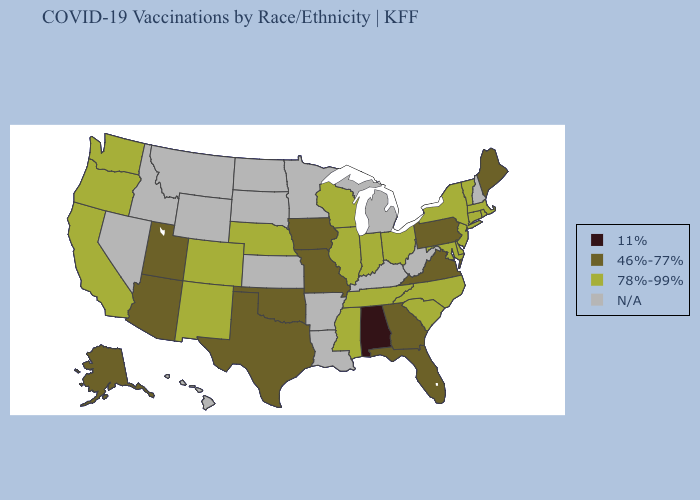Name the states that have a value in the range 78%-99%?
Answer briefly. California, Colorado, Connecticut, Delaware, Illinois, Indiana, Maryland, Massachusetts, Mississippi, Nebraska, New Jersey, New Mexico, New York, North Carolina, Ohio, Oregon, Rhode Island, South Carolina, Tennessee, Vermont, Washington, Wisconsin. What is the highest value in the South ?
Write a very short answer. 78%-99%. Name the states that have a value in the range N/A?
Concise answer only. Arkansas, Hawaii, Idaho, Kansas, Kentucky, Louisiana, Michigan, Minnesota, Montana, Nevada, New Hampshire, North Dakota, South Dakota, West Virginia, Wyoming. Name the states that have a value in the range 11%?
Write a very short answer. Alabama. What is the lowest value in the USA?
Concise answer only. 11%. Name the states that have a value in the range 78%-99%?
Keep it brief. California, Colorado, Connecticut, Delaware, Illinois, Indiana, Maryland, Massachusetts, Mississippi, Nebraska, New Jersey, New Mexico, New York, North Carolina, Ohio, Oregon, Rhode Island, South Carolina, Tennessee, Vermont, Washington, Wisconsin. Does Alabama have the lowest value in the USA?
Short answer required. Yes. Name the states that have a value in the range 78%-99%?
Be succinct. California, Colorado, Connecticut, Delaware, Illinois, Indiana, Maryland, Massachusetts, Mississippi, Nebraska, New Jersey, New Mexico, New York, North Carolina, Ohio, Oregon, Rhode Island, South Carolina, Tennessee, Vermont, Washington, Wisconsin. What is the lowest value in states that border Pennsylvania?
Quick response, please. 78%-99%. Name the states that have a value in the range 11%?
Quick response, please. Alabama. Name the states that have a value in the range N/A?
Be succinct. Arkansas, Hawaii, Idaho, Kansas, Kentucky, Louisiana, Michigan, Minnesota, Montana, Nevada, New Hampshire, North Dakota, South Dakota, West Virginia, Wyoming. Name the states that have a value in the range 11%?
Be succinct. Alabama. What is the value of Kentucky?
Give a very brief answer. N/A. 